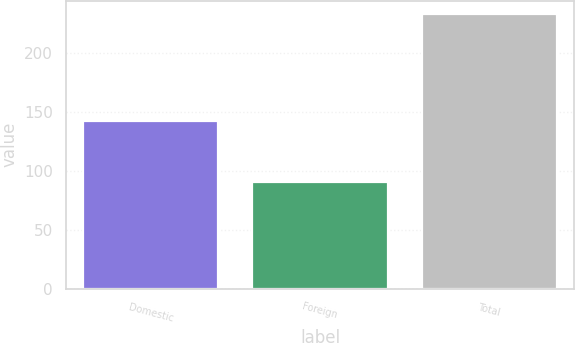<chart> <loc_0><loc_0><loc_500><loc_500><bar_chart><fcel>Domestic<fcel>Foreign<fcel>Total<nl><fcel>141.9<fcel>90.5<fcel>232.4<nl></chart> 